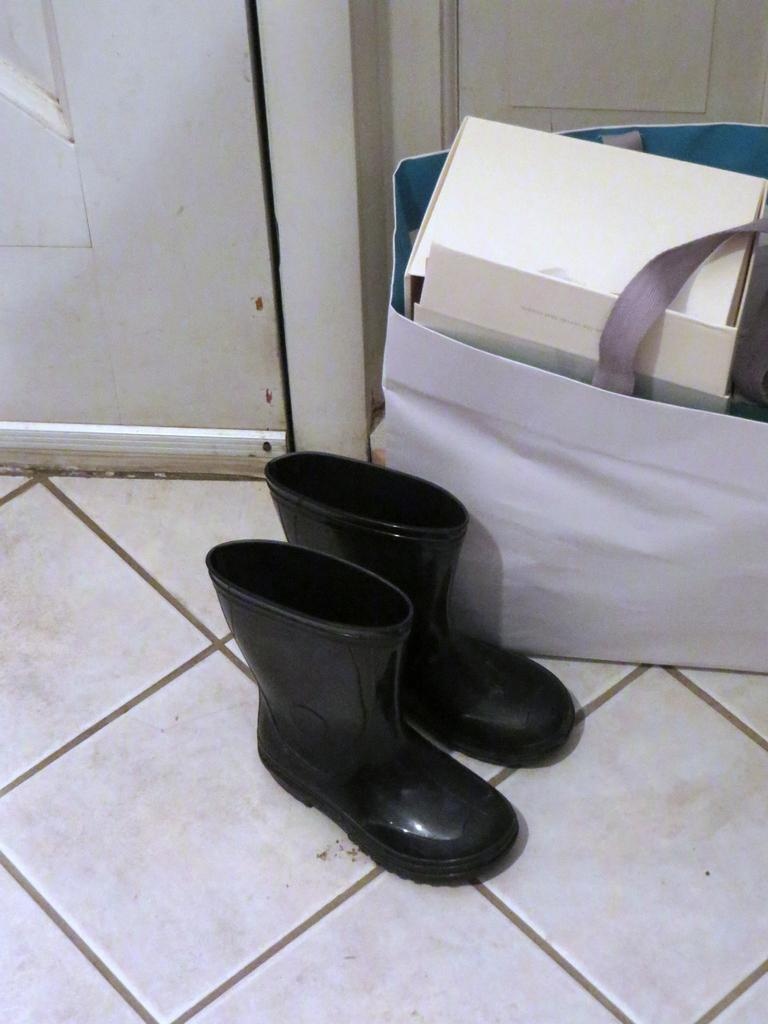What type of footwear is present in the image? There are two black shoes in the image. What color is the bag in the image? There is a white bag in the image. What can be found inside the bag? There are white boxes inside the bag. Where is the door located in the image? The door is visible in the top left side of the image. How many letters are visible on the shoes in the image? There are no letters visible on the shoes in the image; they are plain black shoes. 